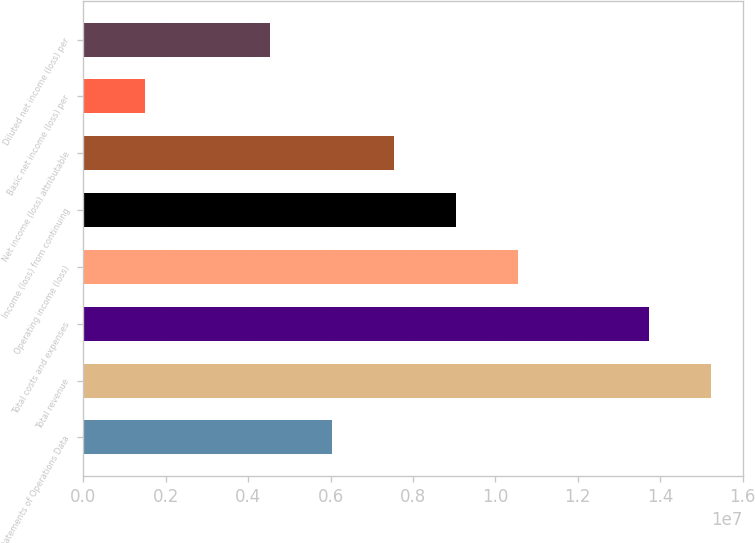Convert chart. <chart><loc_0><loc_0><loc_500><loc_500><bar_chart><fcel>Statements of Operations Data<fcel>Total revenue<fcel>Total costs and expenses<fcel>Operating income (loss)<fcel>Income (loss) from continuing<fcel>Net income (loss) attributable<fcel>Basic net income (loss) per<fcel>Diluted net income (loss) per<nl><fcel>6.02756e+06<fcel>1.52434e+07<fcel>1.37365e+07<fcel>1.05482e+07<fcel>9.04134e+06<fcel>7.53445e+06<fcel>1.50689e+06<fcel>4.52067e+06<nl></chart> 